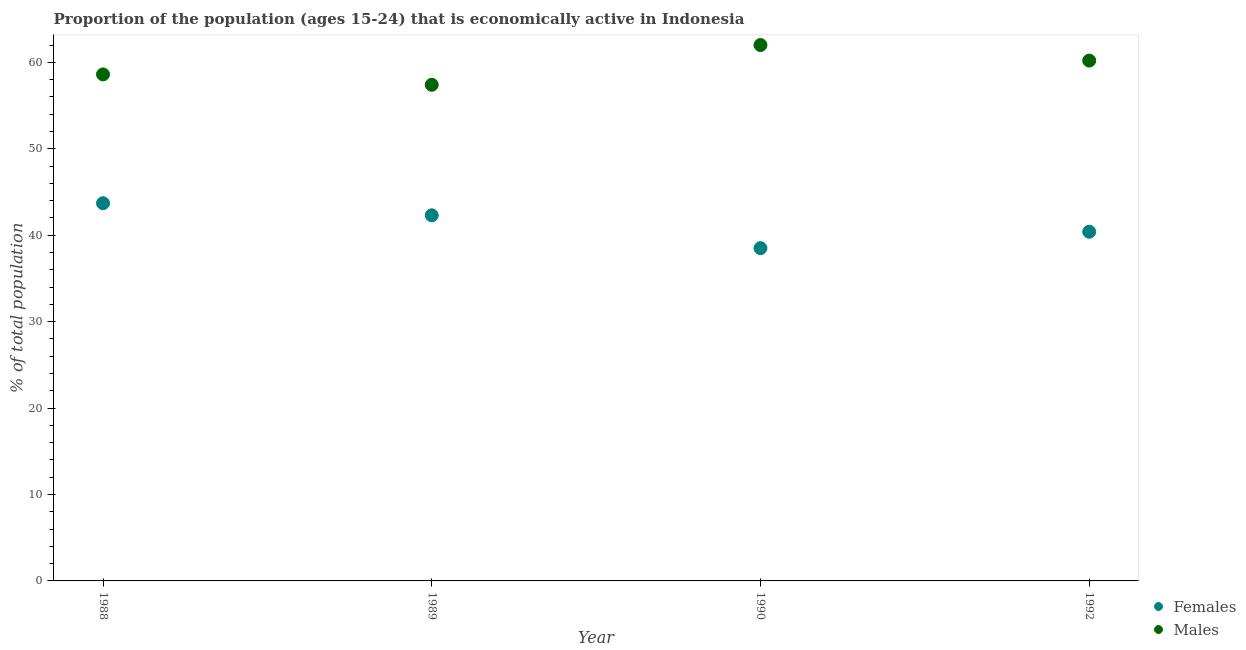How many different coloured dotlines are there?
Provide a short and direct response. 2. What is the percentage of economically active male population in 1992?
Provide a succinct answer. 60.2. Across all years, what is the maximum percentage of economically active female population?
Your answer should be compact. 43.7. Across all years, what is the minimum percentage of economically active female population?
Give a very brief answer. 38.5. In which year was the percentage of economically active male population minimum?
Your response must be concise. 1989. What is the total percentage of economically active female population in the graph?
Offer a very short reply. 164.9. What is the difference between the percentage of economically active male population in 1989 and that in 1990?
Provide a short and direct response. -4.6. What is the difference between the percentage of economically active female population in 1990 and the percentage of economically active male population in 1988?
Offer a terse response. -20.1. What is the average percentage of economically active female population per year?
Keep it short and to the point. 41.23. In the year 1992, what is the difference between the percentage of economically active female population and percentage of economically active male population?
Your response must be concise. -19.8. In how many years, is the percentage of economically active female population greater than 4 %?
Your answer should be compact. 4. What is the ratio of the percentage of economically active female population in 1989 to that in 1992?
Your answer should be compact. 1.05. Is the percentage of economically active female population in 1988 less than that in 1990?
Keep it short and to the point. No. What is the difference between the highest and the second highest percentage of economically active male population?
Offer a very short reply. 1.8. What is the difference between the highest and the lowest percentage of economically active male population?
Provide a succinct answer. 4.6. Does the percentage of economically active male population monotonically increase over the years?
Keep it short and to the point. No. Is the percentage of economically active female population strictly less than the percentage of economically active male population over the years?
Offer a terse response. Yes. How many dotlines are there?
Your answer should be very brief. 2. How many years are there in the graph?
Keep it short and to the point. 4. What is the difference between two consecutive major ticks on the Y-axis?
Offer a very short reply. 10. Does the graph contain grids?
Provide a short and direct response. No. Where does the legend appear in the graph?
Offer a terse response. Bottom right. How many legend labels are there?
Give a very brief answer. 2. How are the legend labels stacked?
Your response must be concise. Vertical. What is the title of the graph?
Make the answer very short. Proportion of the population (ages 15-24) that is economically active in Indonesia. Does "Commercial service imports" appear as one of the legend labels in the graph?
Offer a very short reply. No. What is the label or title of the Y-axis?
Your answer should be compact. % of total population. What is the % of total population in Females in 1988?
Your answer should be compact. 43.7. What is the % of total population in Males in 1988?
Ensure brevity in your answer.  58.6. What is the % of total population in Females in 1989?
Your answer should be compact. 42.3. What is the % of total population of Males in 1989?
Provide a succinct answer. 57.4. What is the % of total population of Females in 1990?
Your answer should be very brief. 38.5. What is the % of total population in Males in 1990?
Make the answer very short. 62. What is the % of total population in Females in 1992?
Make the answer very short. 40.4. What is the % of total population of Males in 1992?
Keep it short and to the point. 60.2. Across all years, what is the maximum % of total population of Females?
Provide a succinct answer. 43.7. Across all years, what is the minimum % of total population of Females?
Ensure brevity in your answer.  38.5. Across all years, what is the minimum % of total population of Males?
Offer a terse response. 57.4. What is the total % of total population in Females in the graph?
Ensure brevity in your answer.  164.9. What is the total % of total population of Males in the graph?
Keep it short and to the point. 238.2. What is the difference between the % of total population of Females in 1988 and that in 1989?
Give a very brief answer. 1.4. What is the difference between the % of total population of Females in 1988 and that in 1990?
Keep it short and to the point. 5.2. What is the difference between the % of total population of Females in 1988 and that in 1992?
Your response must be concise. 3.3. What is the difference between the % of total population in Males in 1988 and that in 1992?
Your answer should be compact. -1.6. What is the difference between the % of total population in Females in 1989 and that in 1990?
Offer a very short reply. 3.8. What is the difference between the % of total population of Males in 1989 and that in 1990?
Your answer should be compact. -4.6. What is the difference between the % of total population in Females in 1989 and that in 1992?
Your answer should be very brief. 1.9. What is the difference between the % of total population of Males in 1990 and that in 1992?
Your response must be concise. 1.8. What is the difference between the % of total population in Females in 1988 and the % of total population in Males in 1989?
Ensure brevity in your answer.  -13.7. What is the difference between the % of total population of Females in 1988 and the % of total population of Males in 1990?
Offer a terse response. -18.3. What is the difference between the % of total population of Females in 1988 and the % of total population of Males in 1992?
Provide a short and direct response. -16.5. What is the difference between the % of total population of Females in 1989 and the % of total population of Males in 1990?
Provide a succinct answer. -19.7. What is the difference between the % of total population in Females in 1989 and the % of total population in Males in 1992?
Your answer should be compact. -17.9. What is the difference between the % of total population in Females in 1990 and the % of total population in Males in 1992?
Make the answer very short. -21.7. What is the average % of total population of Females per year?
Your answer should be compact. 41.23. What is the average % of total population in Males per year?
Make the answer very short. 59.55. In the year 1988, what is the difference between the % of total population in Females and % of total population in Males?
Ensure brevity in your answer.  -14.9. In the year 1989, what is the difference between the % of total population in Females and % of total population in Males?
Your answer should be compact. -15.1. In the year 1990, what is the difference between the % of total population of Females and % of total population of Males?
Your answer should be compact. -23.5. In the year 1992, what is the difference between the % of total population in Females and % of total population in Males?
Your answer should be compact. -19.8. What is the ratio of the % of total population of Females in 1988 to that in 1989?
Make the answer very short. 1.03. What is the ratio of the % of total population in Males in 1988 to that in 1989?
Ensure brevity in your answer.  1.02. What is the ratio of the % of total population in Females in 1988 to that in 1990?
Your response must be concise. 1.14. What is the ratio of the % of total population of Males in 1988 to that in 1990?
Offer a very short reply. 0.95. What is the ratio of the % of total population in Females in 1988 to that in 1992?
Your answer should be very brief. 1.08. What is the ratio of the % of total population of Males in 1988 to that in 1992?
Make the answer very short. 0.97. What is the ratio of the % of total population of Females in 1989 to that in 1990?
Offer a terse response. 1.1. What is the ratio of the % of total population of Males in 1989 to that in 1990?
Offer a very short reply. 0.93. What is the ratio of the % of total population in Females in 1989 to that in 1992?
Your answer should be compact. 1.05. What is the ratio of the % of total population in Males in 1989 to that in 1992?
Keep it short and to the point. 0.95. What is the ratio of the % of total population of Females in 1990 to that in 1992?
Provide a succinct answer. 0.95. What is the ratio of the % of total population of Males in 1990 to that in 1992?
Your response must be concise. 1.03. What is the difference between the highest and the second highest % of total population of Males?
Your answer should be compact. 1.8. 